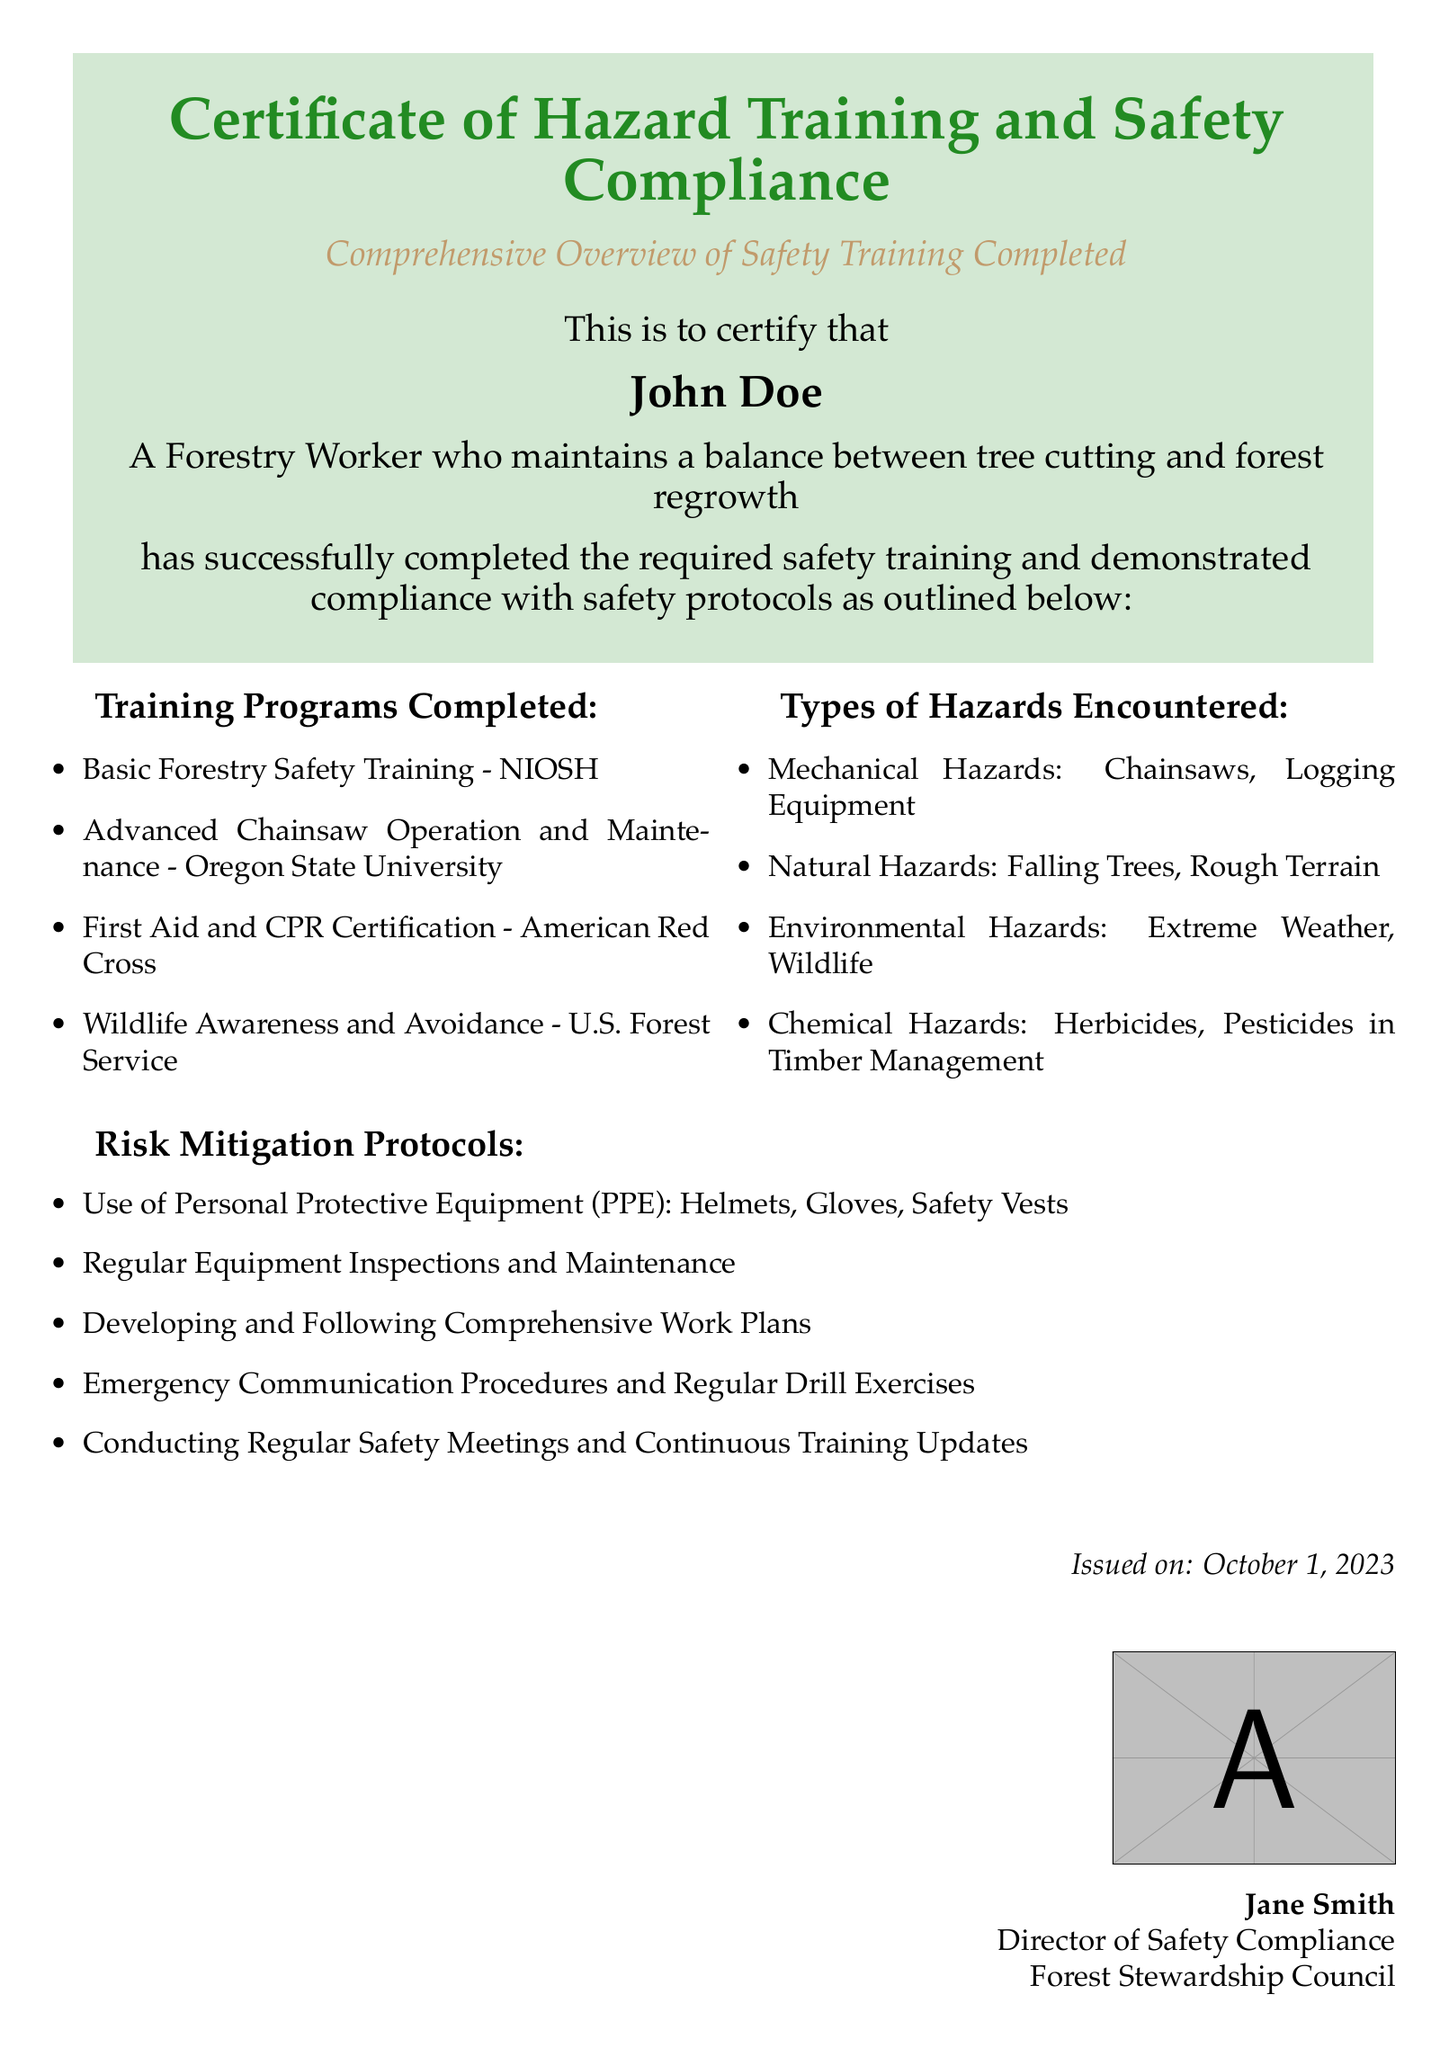what is the name of the certificate? The name of the certificate is found in the title section of the document, which states "Certificate of Hazard Training and Safety Compliance."
Answer: Certificate of Hazard Training and Safety Compliance who completed the safety training? The document specifically mentions the individual who completed the training as John Doe.
Answer: John Doe what is one type of hazard encountered in forestry work? The document lists several types of hazards, one of which is "Mechanical Hazards: Chainsaws, Logging Equipment."
Answer: Mechanical Hazards how many training programs are listed in the document? The document presents a list of training programs completed, which totals four programs.
Answer: Four what is one protocol followed to mitigate risks? The document outlines multiple risk mitigation protocols, one of which is "Use of Personal Protective Equipment (PPE): Helmets, Gloves, Safety Vests."
Answer: Use of Personal Protective Equipment (PPE) who issued the certificate? The issuer of the certificate is mentioned at the bottom of the document, citing "Jane Smith."
Answer: Jane Smith on what date was the certificate issued? The issuance date is stated clearly in the document as "October 1, 2023."
Answer: October 1, 2023 which organization is mentioned in the certificate? The document includes the name of the issuing organization, which is "Forest Stewardship Council."
Answer: Forest Stewardship Council what type of certification is mentioned related to first aid? The document lists a specific certification for first aid, which is "First Aid and CPR Certification."
Answer: First Aid and CPR Certification 